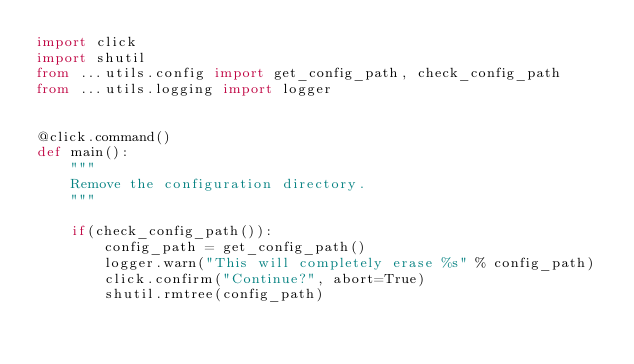Convert code to text. <code><loc_0><loc_0><loc_500><loc_500><_Python_>import click
import shutil
from ...utils.config import get_config_path, check_config_path
from ...utils.logging import logger


@click.command()
def main():
    """
    Remove the configuration directory.
    """

    if(check_config_path()):
        config_path = get_config_path()
        logger.warn("This will completely erase %s" % config_path)
        click.confirm("Continue?", abort=True)
        shutil.rmtree(config_path)
</code> 